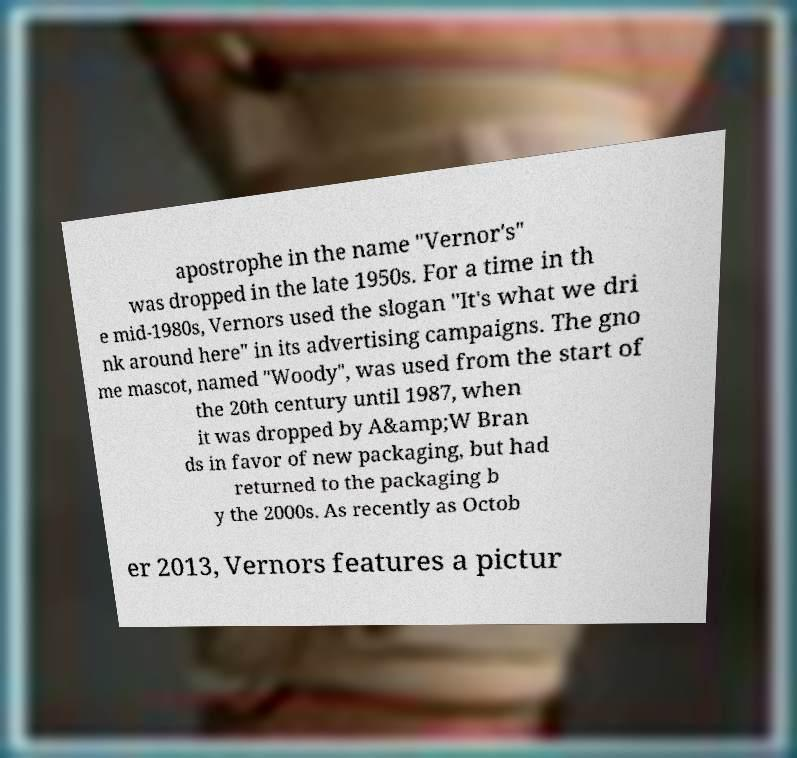Could you assist in decoding the text presented in this image and type it out clearly? apostrophe in the name "Vernor's" was dropped in the late 1950s. For a time in th e mid-1980s, Vernors used the slogan "It's what we dri nk around here" in its advertising campaigns. The gno me mascot, named "Woody", was used from the start of the 20th century until 1987, when it was dropped by A&amp;W Bran ds in favor of new packaging, but had returned to the packaging b y the 2000s. As recently as Octob er 2013, Vernors features a pictur 